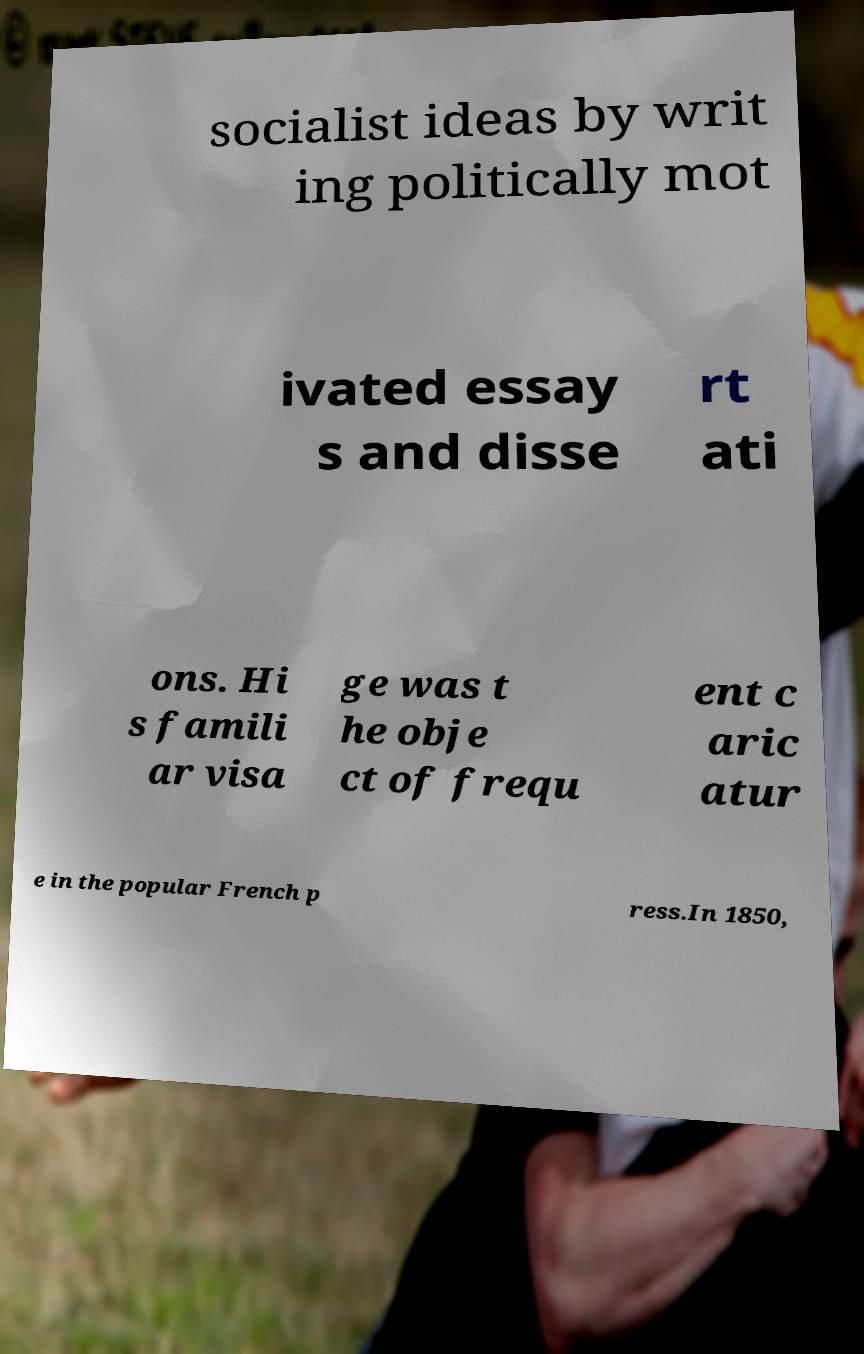Please identify and transcribe the text found in this image. socialist ideas by writ ing politically mot ivated essay s and disse rt ati ons. Hi s famili ar visa ge was t he obje ct of frequ ent c aric atur e in the popular French p ress.In 1850, 